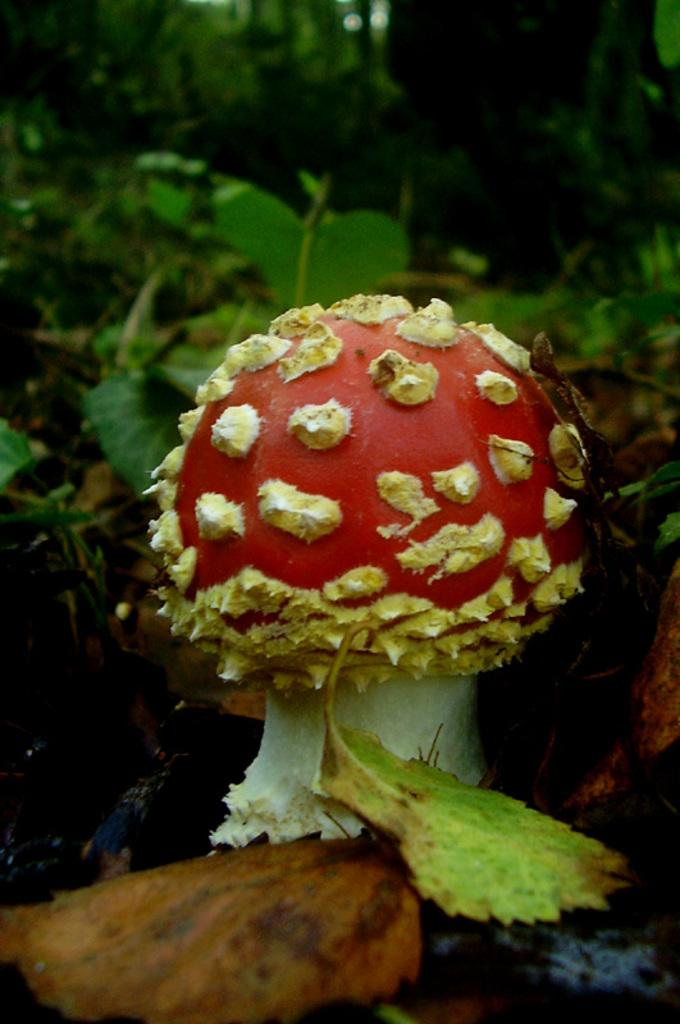What is the main subject of the image? The main subject of the image is a mushroom. Can you describe the colors of the mushroom? The mushroom is red, cream, and white in color. What other elements can be seen in the image besides the mushroom? There are leaves in the image. How would you describe the color of the leaves? The leaves are green and brown in color. What can be seen in the background of the image? There are trees in the background of the image. What type of horn is being used by the manager in the image? There is no manager or horn present in the image; it features a mushroom, leaves, and trees. 